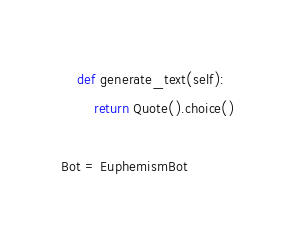Convert code to text. <code><loc_0><loc_0><loc_500><loc_500><_Python_>    def generate_text(self):
        return Quote().choice()
   
Bot = EuphemismBot
</code> 